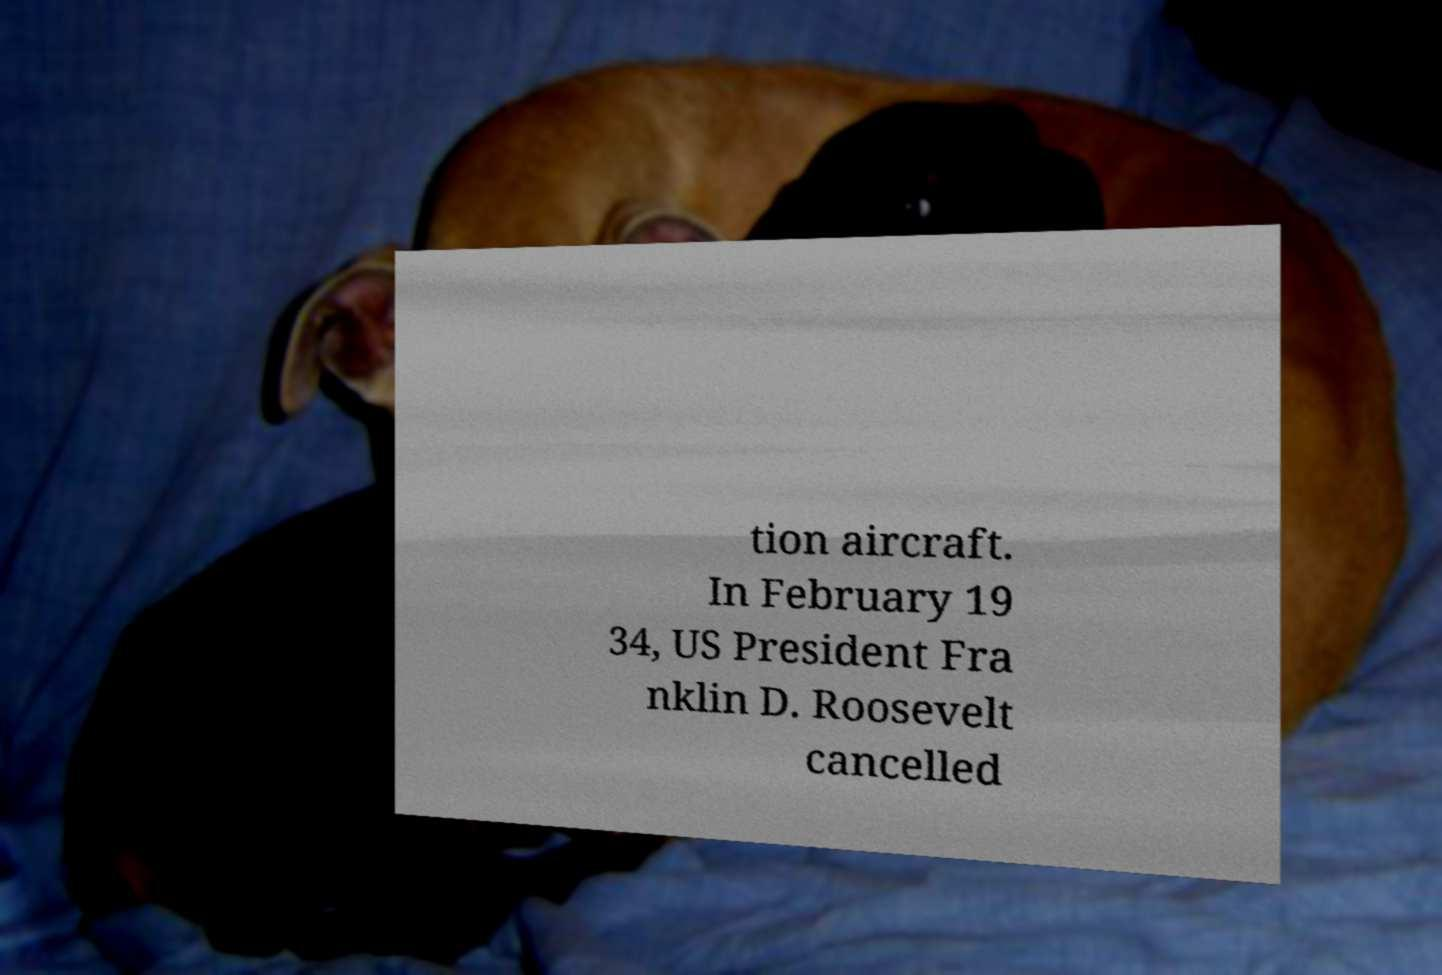I need the written content from this picture converted into text. Can you do that? tion aircraft. In February 19 34, US President Fra nklin D. Roosevelt cancelled 